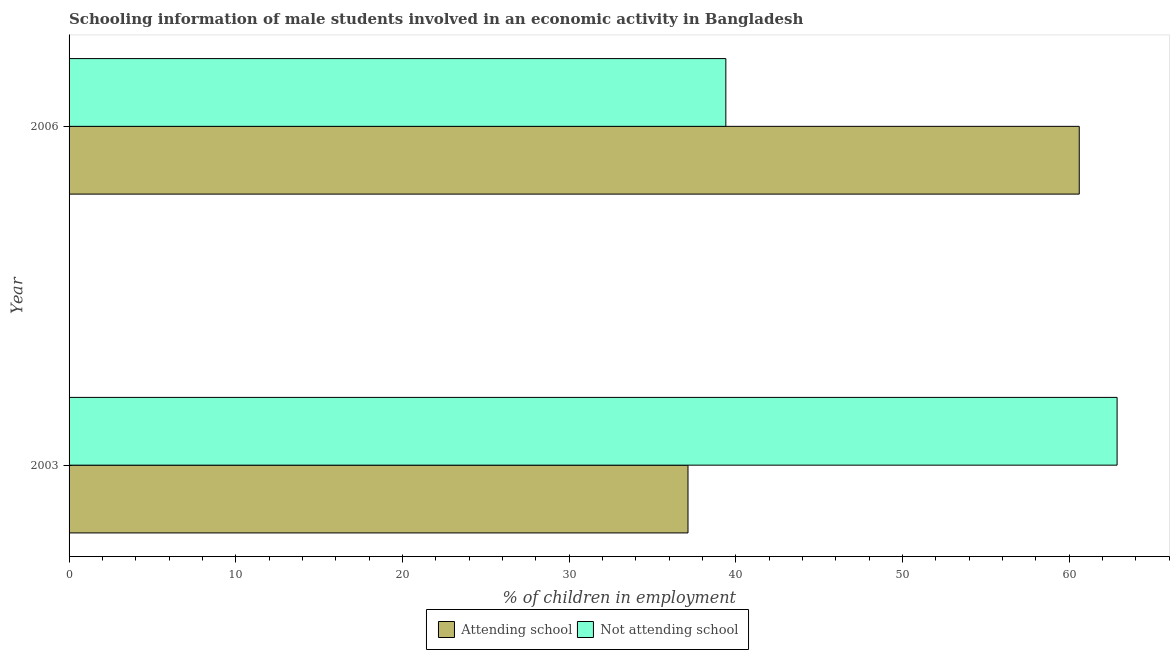How many different coloured bars are there?
Provide a short and direct response. 2. How many groups of bars are there?
Your response must be concise. 2. Are the number of bars on each tick of the Y-axis equal?
Your answer should be very brief. Yes. How many bars are there on the 1st tick from the top?
Offer a very short reply. 2. What is the label of the 2nd group of bars from the top?
Provide a short and direct response. 2003. What is the percentage of employed males who are attending school in 2003?
Your answer should be compact. 37.13. Across all years, what is the maximum percentage of employed males who are not attending school?
Your response must be concise. 62.87. Across all years, what is the minimum percentage of employed males who are attending school?
Provide a succinct answer. 37.13. In which year was the percentage of employed males who are attending school maximum?
Your answer should be very brief. 2006. What is the total percentage of employed males who are attending school in the graph?
Ensure brevity in your answer.  97.73. What is the difference between the percentage of employed males who are attending school in 2003 and that in 2006?
Keep it short and to the point. -23.47. What is the difference between the percentage of employed males who are not attending school in 2003 and the percentage of employed males who are attending school in 2006?
Offer a terse response. 2.27. What is the average percentage of employed males who are attending school per year?
Provide a short and direct response. 48.87. In the year 2006, what is the difference between the percentage of employed males who are attending school and percentage of employed males who are not attending school?
Your response must be concise. 21.2. In how many years, is the percentage of employed males who are not attending school greater than 12 %?
Your response must be concise. 2. What is the ratio of the percentage of employed males who are attending school in 2003 to that in 2006?
Your answer should be compact. 0.61. Is the difference between the percentage of employed males who are attending school in 2003 and 2006 greater than the difference between the percentage of employed males who are not attending school in 2003 and 2006?
Give a very brief answer. No. What does the 2nd bar from the top in 2006 represents?
Give a very brief answer. Attending school. What does the 2nd bar from the bottom in 2006 represents?
Make the answer very short. Not attending school. Are all the bars in the graph horizontal?
Ensure brevity in your answer.  Yes. How many years are there in the graph?
Offer a very short reply. 2. Are the values on the major ticks of X-axis written in scientific E-notation?
Your response must be concise. No. How many legend labels are there?
Make the answer very short. 2. What is the title of the graph?
Ensure brevity in your answer.  Schooling information of male students involved in an economic activity in Bangladesh. Does "Transport services" appear as one of the legend labels in the graph?
Ensure brevity in your answer.  No. What is the label or title of the X-axis?
Ensure brevity in your answer.  % of children in employment. What is the label or title of the Y-axis?
Offer a terse response. Year. What is the % of children in employment in Attending school in 2003?
Keep it short and to the point. 37.13. What is the % of children in employment of Not attending school in 2003?
Your answer should be compact. 62.87. What is the % of children in employment of Attending school in 2006?
Ensure brevity in your answer.  60.6. What is the % of children in employment in Not attending school in 2006?
Provide a short and direct response. 39.4. Across all years, what is the maximum % of children in employment of Attending school?
Offer a very short reply. 60.6. Across all years, what is the maximum % of children in employment in Not attending school?
Keep it short and to the point. 62.87. Across all years, what is the minimum % of children in employment of Attending school?
Make the answer very short. 37.13. Across all years, what is the minimum % of children in employment in Not attending school?
Give a very brief answer. 39.4. What is the total % of children in employment in Attending school in the graph?
Give a very brief answer. 97.73. What is the total % of children in employment in Not attending school in the graph?
Offer a terse response. 102.27. What is the difference between the % of children in employment in Attending school in 2003 and that in 2006?
Offer a terse response. -23.47. What is the difference between the % of children in employment in Not attending school in 2003 and that in 2006?
Offer a terse response. 23.47. What is the difference between the % of children in employment of Attending school in 2003 and the % of children in employment of Not attending school in 2006?
Give a very brief answer. -2.27. What is the average % of children in employment in Attending school per year?
Your answer should be very brief. 48.86. What is the average % of children in employment in Not attending school per year?
Offer a very short reply. 51.14. In the year 2003, what is the difference between the % of children in employment in Attending school and % of children in employment in Not attending school?
Your answer should be compact. -25.74. In the year 2006, what is the difference between the % of children in employment of Attending school and % of children in employment of Not attending school?
Offer a very short reply. 21.2. What is the ratio of the % of children in employment of Attending school in 2003 to that in 2006?
Offer a very short reply. 0.61. What is the ratio of the % of children in employment in Not attending school in 2003 to that in 2006?
Your answer should be very brief. 1.6. What is the difference between the highest and the second highest % of children in employment in Attending school?
Give a very brief answer. 23.47. What is the difference between the highest and the second highest % of children in employment in Not attending school?
Provide a succinct answer. 23.47. What is the difference between the highest and the lowest % of children in employment in Attending school?
Offer a very short reply. 23.47. What is the difference between the highest and the lowest % of children in employment of Not attending school?
Keep it short and to the point. 23.47. 